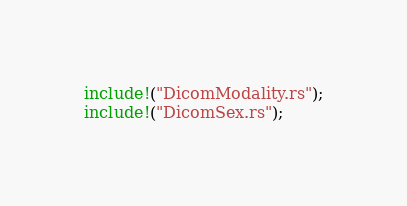Convert code to text. <code><loc_0><loc_0><loc_500><loc_500><_Rust_>
include!("DicomModality.rs");
include!("DicomSex.rs");
</code> 